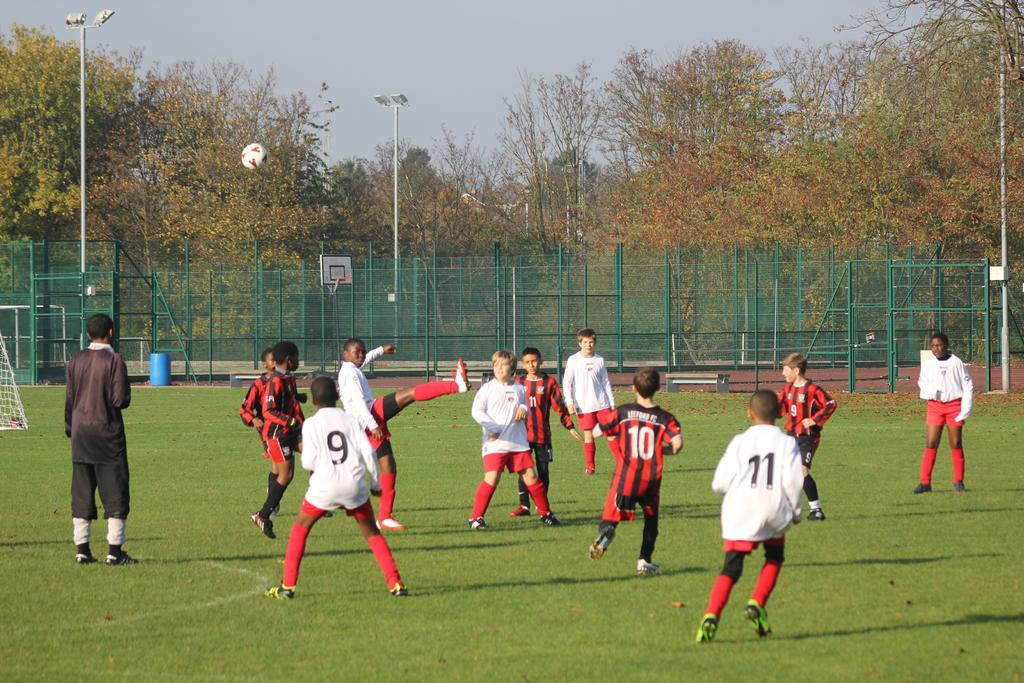Provide a one-sentence caption for the provided image. Several soccer players, including jersey numbers 9 and 11, are playing. 